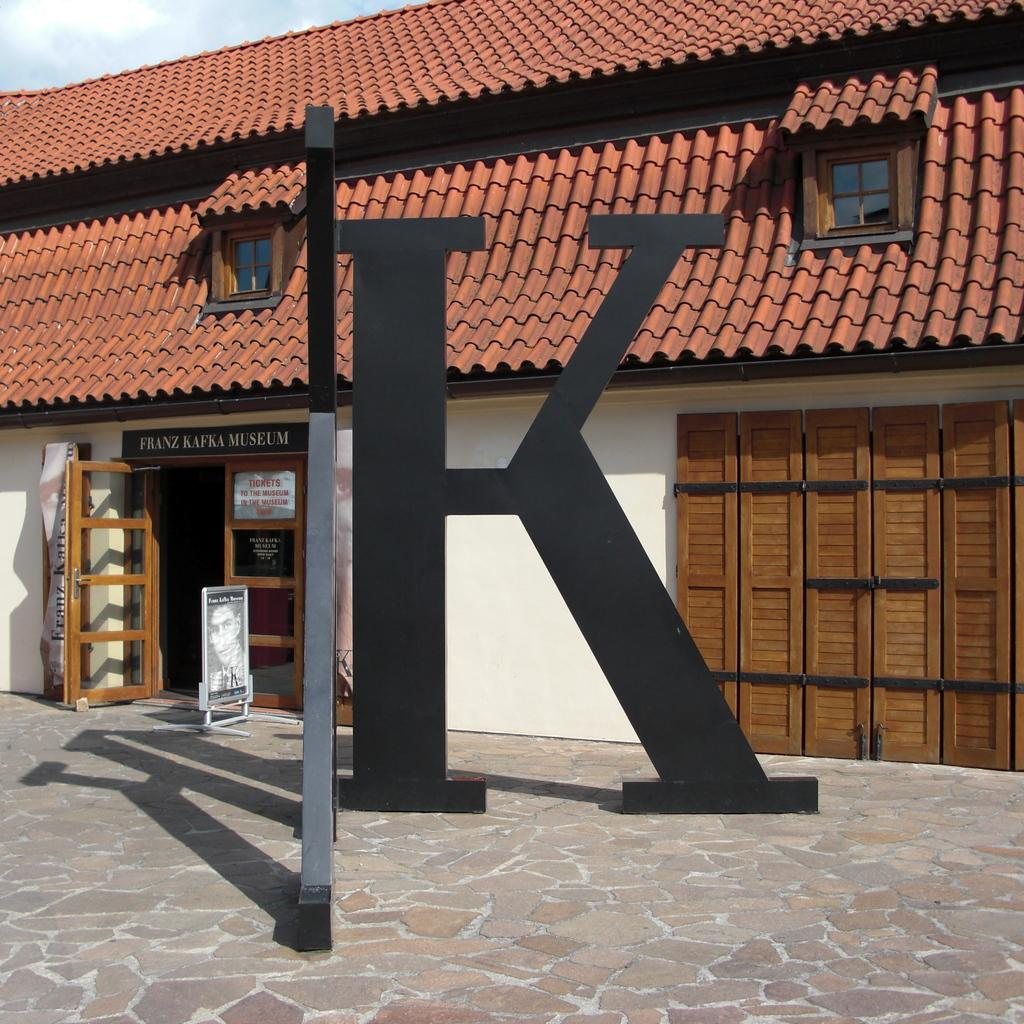What type of objects can be seen in the image? There are metal rods, a window, a door, and a board in the image. What type of structure is visible in the image? There is a house in the image. What is visible in the background of the image? The sky is visible in the image. Can you determine the time of day the image was taken? The image was likely taken during the day, as the sky is visible and not dark. How many bells are hanging from the metal rods in the image? There are no bells present in the image; it only features metal rods. What type of care is being provided to the house in the image? There is no indication of any care being provided to the house in the image. 